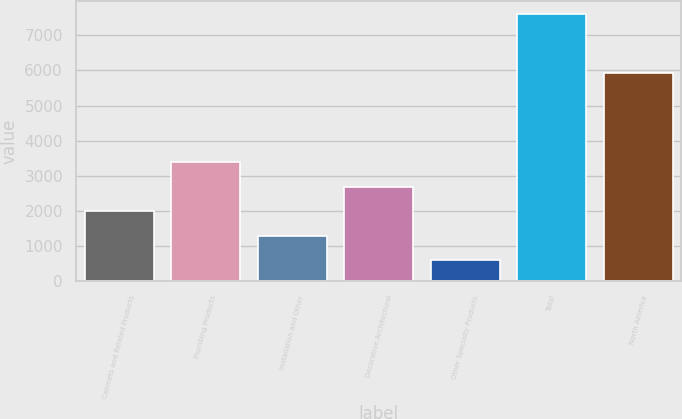Convert chart to OTSL. <chart><loc_0><loc_0><loc_500><loc_500><bar_chart><fcel>Cabinets and Related Products<fcel>Plumbing Products<fcel>Installation and Other<fcel>Decorative Architectural<fcel>Other Specialty Products<fcel>Total<fcel>North America<nl><fcel>1995.2<fcel>3394.4<fcel>1295.6<fcel>2694.8<fcel>596<fcel>7592<fcel>5929<nl></chart> 